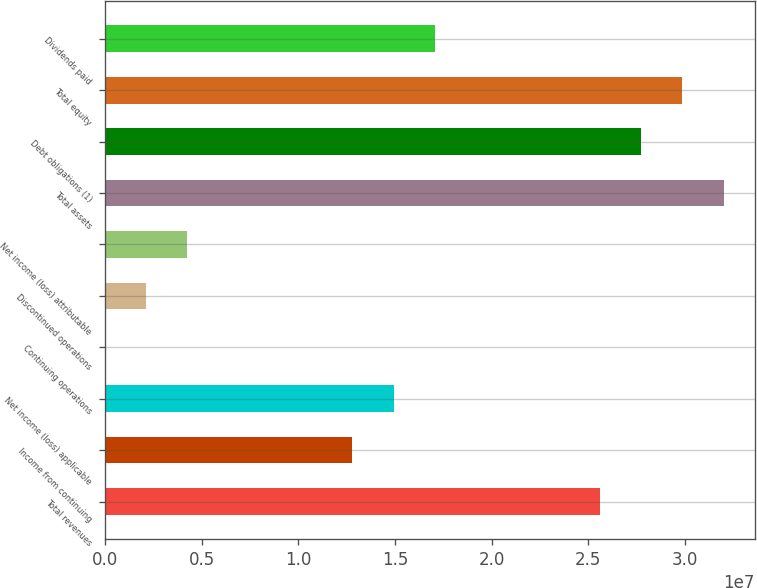Convert chart. <chart><loc_0><loc_0><loc_500><loc_500><bar_chart><fcel>Total revenues<fcel>Income from continuing<fcel>Net income (loss) applicable<fcel>Continuing operations<fcel>Discontinued operations<fcel>Net income (loss) attributable<fcel>Total assets<fcel>Debt obligations (1)<fcel>Total equity<fcel>Dividends paid<nl><fcel>2.55977e+07<fcel>1.27989e+07<fcel>1.4932e+07<fcel>0.56<fcel>2.13314e+06<fcel>4.26629e+06<fcel>3.19972e+07<fcel>2.77309e+07<fcel>2.9864e+07<fcel>1.70651e+07<nl></chart> 